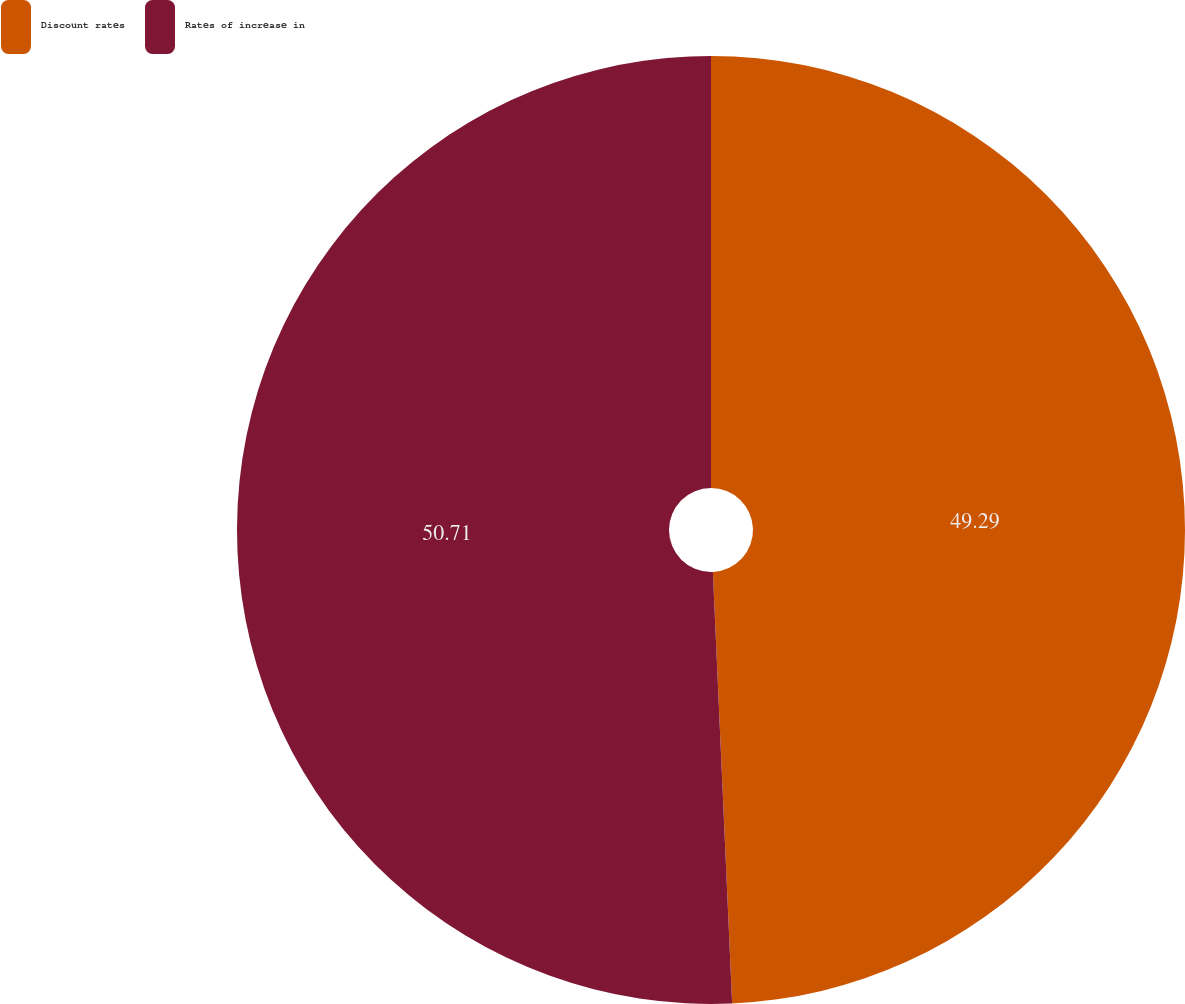<chart> <loc_0><loc_0><loc_500><loc_500><pie_chart><fcel>Discount rates<fcel>Rates of increase in<nl><fcel>49.29%<fcel>50.71%<nl></chart> 